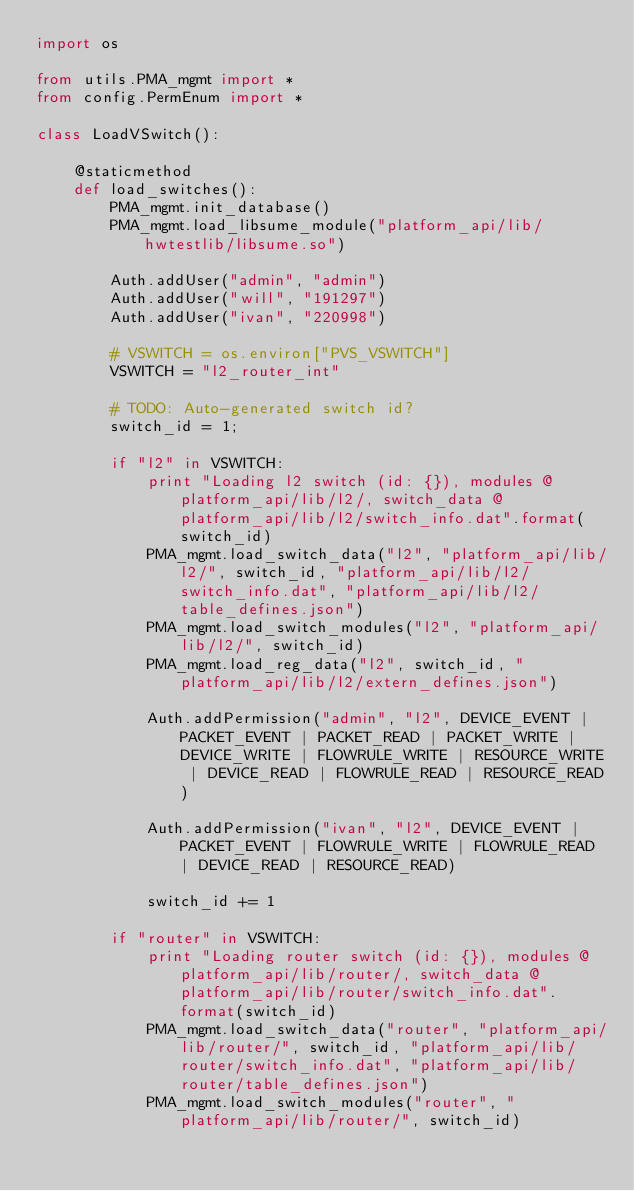Convert code to text. <code><loc_0><loc_0><loc_500><loc_500><_Python_>import os

from utils.PMA_mgmt import *
from config.PermEnum import *

class LoadVSwitch():

	@staticmethod
	def load_switches():
		PMA_mgmt.init_database()
		PMA_mgmt.load_libsume_module("platform_api/lib/hwtestlib/libsume.so")

		Auth.addUser("admin", "admin")
		Auth.addUser("will", "191297")
		Auth.addUser("ivan", "220998")

		# VSWITCH = os.environ["PVS_VSWITCH"]
		VSWITCH = "l2_router_int"

		# TODO: Auto-generated switch id?
		switch_id = 1;

		if "l2" in VSWITCH:
			print "Loading l2 switch (id: {}), modules @ platform_api/lib/l2/, switch_data @ platform_api/lib/l2/switch_info.dat".format(switch_id)
			PMA_mgmt.load_switch_data("l2", "platform_api/lib/l2/", switch_id, "platform_api/lib/l2/switch_info.dat", "platform_api/lib/l2/table_defines.json")
			PMA_mgmt.load_switch_modules("l2", "platform_api/lib/l2/", switch_id)
			PMA_mgmt.load_reg_data("l2", switch_id, "platform_api/lib/l2/extern_defines.json")

			Auth.addPermission("admin", "l2", DEVICE_EVENT | PACKET_EVENT | PACKET_READ | PACKET_WRITE | DEVICE_WRITE | FLOWRULE_WRITE | RESOURCE_WRITE | DEVICE_READ | FLOWRULE_READ | RESOURCE_READ)

			Auth.addPermission("ivan", "l2", DEVICE_EVENT | PACKET_EVENT | FLOWRULE_WRITE | FLOWRULE_READ | DEVICE_READ | RESOURCE_READ)

			switch_id += 1

		if "router" in VSWITCH:
			print "Loading router switch (id: {}), modules @ platform_api/lib/router/, switch_data @ platform_api/lib/router/switch_info.dat".format(switch_id)
			PMA_mgmt.load_switch_data("router", "platform_api/lib/router/", switch_id, "platform_api/lib/router/switch_info.dat", "platform_api/lib/router/table_defines.json")
			PMA_mgmt.load_switch_modules("router", "platform_api/lib/router/", switch_id)</code> 